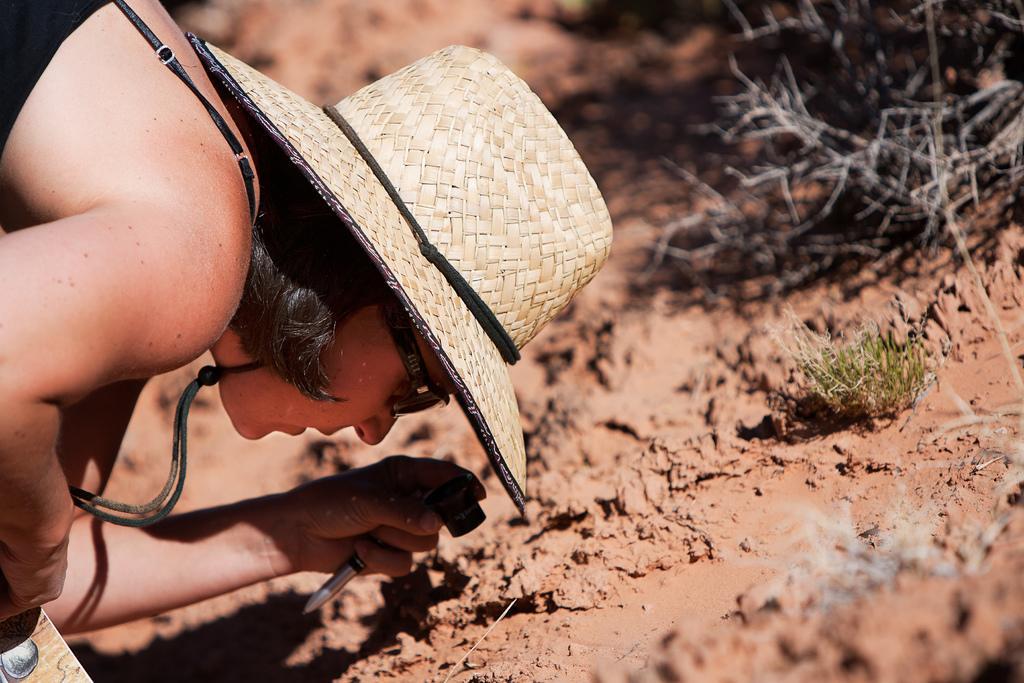Describe this image in one or two sentences. In the foreground of this image, on the left, there is a woman wearing a hat holding few objects. On the right, there is mud, grass and few branches without leaves. 